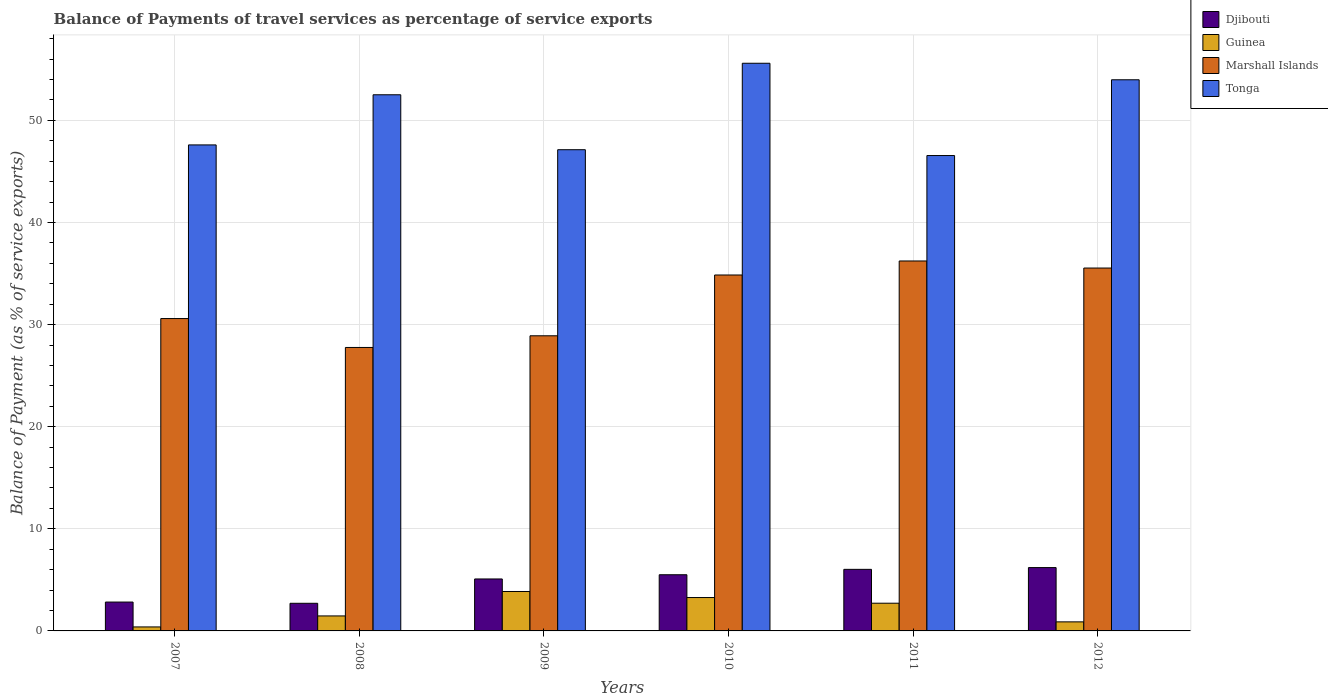How many groups of bars are there?
Give a very brief answer. 6. Are the number of bars on each tick of the X-axis equal?
Your response must be concise. Yes. How many bars are there on the 6th tick from the right?
Provide a short and direct response. 4. What is the balance of payments of travel services in Guinea in 2009?
Offer a terse response. 3.86. Across all years, what is the maximum balance of payments of travel services in Guinea?
Keep it short and to the point. 3.86. Across all years, what is the minimum balance of payments of travel services in Guinea?
Ensure brevity in your answer.  0.39. In which year was the balance of payments of travel services in Guinea minimum?
Keep it short and to the point. 2007. What is the total balance of payments of travel services in Guinea in the graph?
Keep it short and to the point. 12.59. What is the difference between the balance of payments of travel services in Djibouti in 2010 and that in 2011?
Keep it short and to the point. -0.53. What is the difference between the balance of payments of travel services in Tonga in 2008 and the balance of payments of travel services in Marshall Islands in 2010?
Your response must be concise. 17.65. What is the average balance of payments of travel services in Djibouti per year?
Keep it short and to the point. 4.73. In the year 2011, what is the difference between the balance of payments of travel services in Tonga and balance of payments of travel services in Marshall Islands?
Provide a short and direct response. 10.32. In how many years, is the balance of payments of travel services in Guinea greater than 10 %?
Your answer should be compact. 0. What is the ratio of the balance of payments of travel services in Guinea in 2009 to that in 2010?
Offer a terse response. 1.18. Is the balance of payments of travel services in Tonga in 2007 less than that in 2012?
Your response must be concise. Yes. Is the difference between the balance of payments of travel services in Tonga in 2010 and 2012 greater than the difference between the balance of payments of travel services in Marshall Islands in 2010 and 2012?
Your response must be concise. Yes. What is the difference between the highest and the second highest balance of payments of travel services in Guinea?
Provide a succinct answer. 0.59. What is the difference between the highest and the lowest balance of payments of travel services in Guinea?
Offer a very short reply. 3.47. Is the sum of the balance of payments of travel services in Marshall Islands in 2007 and 2012 greater than the maximum balance of payments of travel services in Tonga across all years?
Provide a short and direct response. Yes. What does the 3rd bar from the left in 2007 represents?
Offer a terse response. Marshall Islands. What does the 1st bar from the right in 2011 represents?
Your answer should be very brief. Tonga. How many years are there in the graph?
Provide a succinct answer. 6. Where does the legend appear in the graph?
Make the answer very short. Top right. What is the title of the graph?
Keep it short and to the point. Balance of Payments of travel services as percentage of service exports. What is the label or title of the Y-axis?
Keep it short and to the point. Balance of Payment (as % of service exports). What is the Balance of Payment (as % of service exports) in Djibouti in 2007?
Keep it short and to the point. 2.83. What is the Balance of Payment (as % of service exports) in Guinea in 2007?
Ensure brevity in your answer.  0.39. What is the Balance of Payment (as % of service exports) in Marshall Islands in 2007?
Your answer should be compact. 30.59. What is the Balance of Payment (as % of service exports) in Tonga in 2007?
Provide a succinct answer. 47.6. What is the Balance of Payment (as % of service exports) in Djibouti in 2008?
Offer a terse response. 2.71. What is the Balance of Payment (as % of service exports) of Guinea in 2008?
Provide a succinct answer. 1.47. What is the Balance of Payment (as % of service exports) of Marshall Islands in 2008?
Make the answer very short. 27.76. What is the Balance of Payment (as % of service exports) in Tonga in 2008?
Your answer should be very brief. 52.51. What is the Balance of Payment (as % of service exports) of Djibouti in 2009?
Make the answer very short. 5.09. What is the Balance of Payment (as % of service exports) in Guinea in 2009?
Your response must be concise. 3.86. What is the Balance of Payment (as % of service exports) of Marshall Islands in 2009?
Your answer should be very brief. 28.9. What is the Balance of Payment (as % of service exports) in Tonga in 2009?
Your answer should be very brief. 47.13. What is the Balance of Payment (as % of service exports) of Djibouti in 2010?
Ensure brevity in your answer.  5.5. What is the Balance of Payment (as % of service exports) in Guinea in 2010?
Provide a short and direct response. 3.27. What is the Balance of Payment (as % of service exports) in Marshall Islands in 2010?
Provide a succinct answer. 34.86. What is the Balance of Payment (as % of service exports) in Tonga in 2010?
Keep it short and to the point. 55.59. What is the Balance of Payment (as % of service exports) of Djibouti in 2011?
Provide a short and direct response. 6.03. What is the Balance of Payment (as % of service exports) of Guinea in 2011?
Give a very brief answer. 2.71. What is the Balance of Payment (as % of service exports) of Marshall Islands in 2011?
Offer a very short reply. 36.23. What is the Balance of Payment (as % of service exports) in Tonga in 2011?
Make the answer very short. 46.55. What is the Balance of Payment (as % of service exports) in Djibouti in 2012?
Your answer should be compact. 6.2. What is the Balance of Payment (as % of service exports) of Guinea in 2012?
Ensure brevity in your answer.  0.89. What is the Balance of Payment (as % of service exports) in Marshall Islands in 2012?
Your response must be concise. 35.54. What is the Balance of Payment (as % of service exports) in Tonga in 2012?
Offer a very short reply. 53.97. Across all years, what is the maximum Balance of Payment (as % of service exports) of Djibouti?
Keep it short and to the point. 6.2. Across all years, what is the maximum Balance of Payment (as % of service exports) of Guinea?
Your response must be concise. 3.86. Across all years, what is the maximum Balance of Payment (as % of service exports) in Marshall Islands?
Make the answer very short. 36.23. Across all years, what is the maximum Balance of Payment (as % of service exports) of Tonga?
Provide a succinct answer. 55.59. Across all years, what is the minimum Balance of Payment (as % of service exports) in Djibouti?
Keep it short and to the point. 2.71. Across all years, what is the minimum Balance of Payment (as % of service exports) of Guinea?
Your answer should be compact. 0.39. Across all years, what is the minimum Balance of Payment (as % of service exports) of Marshall Islands?
Offer a terse response. 27.76. Across all years, what is the minimum Balance of Payment (as % of service exports) in Tonga?
Provide a short and direct response. 46.55. What is the total Balance of Payment (as % of service exports) of Djibouti in the graph?
Ensure brevity in your answer.  28.36. What is the total Balance of Payment (as % of service exports) in Guinea in the graph?
Make the answer very short. 12.59. What is the total Balance of Payment (as % of service exports) in Marshall Islands in the graph?
Your response must be concise. 193.88. What is the total Balance of Payment (as % of service exports) of Tonga in the graph?
Your response must be concise. 303.35. What is the difference between the Balance of Payment (as % of service exports) in Djibouti in 2007 and that in 2008?
Give a very brief answer. 0.12. What is the difference between the Balance of Payment (as % of service exports) in Guinea in 2007 and that in 2008?
Your answer should be compact. -1.08. What is the difference between the Balance of Payment (as % of service exports) in Marshall Islands in 2007 and that in 2008?
Your answer should be very brief. 2.83. What is the difference between the Balance of Payment (as % of service exports) of Tonga in 2007 and that in 2008?
Give a very brief answer. -4.91. What is the difference between the Balance of Payment (as % of service exports) in Djibouti in 2007 and that in 2009?
Your answer should be compact. -2.26. What is the difference between the Balance of Payment (as % of service exports) in Guinea in 2007 and that in 2009?
Offer a terse response. -3.47. What is the difference between the Balance of Payment (as % of service exports) of Marshall Islands in 2007 and that in 2009?
Provide a succinct answer. 1.69. What is the difference between the Balance of Payment (as % of service exports) in Tonga in 2007 and that in 2009?
Give a very brief answer. 0.47. What is the difference between the Balance of Payment (as % of service exports) in Djibouti in 2007 and that in 2010?
Provide a succinct answer. -2.67. What is the difference between the Balance of Payment (as % of service exports) in Guinea in 2007 and that in 2010?
Keep it short and to the point. -2.88. What is the difference between the Balance of Payment (as % of service exports) of Marshall Islands in 2007 and that in 2010?
Offer a very short reply. -4.27. What is the difference between the Balance of Payment (as % of service exports) of Tonga in 2007 and that in 2010?
Provide a short and direct response. -8. What is the difference between the Balance of Payment (as % of service exports) of Djibouti in 2007 and that in 2011?
Provide a short and direct response. -3.2. What is the difference between the Balance of Payment (as % of service exports) of Guinea in 2007 and that in 2011?
Your answer should be compact. -2.32. What is the difference between the Balance of Payment (as % of service exports) of Marshall Islands in 2007 and that in 2011?
Offer a very short reply. -5.64. What is the difference between the Balance of Payment (as % of service exports) in Tonga in 2007 and that in 2011?
Offer a terse response. 1.04. What is the difference between the Balance of Payment (as % of service exports) in Djibouti in 2007 and that in 2012?
Provide a succinct answer. -3.38. What is the difference between the Balance of Payment (as % of service exports) of Guinea in 2007 and that in 2012?
Provide a succinct answer. -0.5. What is the difference between the Balance of Payment (as % of service exports) of Marshall Islands in 2007 and that in 2012?
Make the answer very short. -4.95. What is the difference between the Balance of Payment (as % of service exports) in Tonga in 2007 and that in 2012?
Offer a very short reply. -6.38. What is the difference between the Balance of Payment (as % of service exports) in Djibouti in 2008 and that in 2009?
Give a very brief answer. -2.38. What is the difference between the Balance of Payment (as % of service exports) of Guinea in 2008 and that in 2009?
Offer a very short reply. -2.39. What is the difference between the Balance of Payment (as % of service exports) in Marshall Islands in 2008 and that in 2009?
Make the answer very short. -1.14. What is the difference between the Balance of Payment (as % of service exports) of Tonga in 2008 and that in 2009?
Offer a very short reply. 5.38. What is the difference between the Balance of Payment (as % of service exports) of Djibouti in 2008 and that in 2010?
Make the answer very short. -2.79. What is the difference between the Balance of Payment (as % of service exports) in Guinea in 2008 and that in 2010?
Offer a terse response. -1.8. What is the difference between the Balance of Payment (as % of service exports) of Marshall Islands in 2008 and that in 2010?
Your response must be concise. -7.1. What is the difference between the Balance of Payment (as % of service exports) of Tonga in 2008 and that in 2010?
Your answer should be very brief. -3.09. What is the difference between the Balance of Payment (as % of service exports) of Djibouti in 2008 and that in 2011?
Your response must be concise. -3.32. What is the difference between the Balance of Payment (as % of service exports) of Guinea in 2008 and that in 2011?
Keep it short and to the point. -1.25. What is the difference between the Balance of Payment (as % of service exports) of Marshall Islands in 2008 and that in 2011?
Your response must be concise. -8.47. What is the difference between the Balance of Payment (as % of service exports) in Tonga in 2008 and that in 2011?
Provide a succinct answer. 5.95. What is the difference between the Balance of Payment (as % of service exports) in Djibouti in 2008 and that in 2012?
Provide a short and direct response. -3.5. What is the difference between the Balance of Payment (as % of service exports) of Guinea in 2008 and that in 2012?
Keep it short and to the point. 0.58. What is the difference between the Balance of Payment (as % of service exports) of Marshall Islands in 2008 and that in 2012?
Give a very brief answer. -7.78. What is the difference between the Balance of Payment (as % of service exports) of Tonga in 2008 and that in 2012?
Provide a short and direct response. -1.47. What is the difference between the Balance of Payment (as % of service exports) of Djibouti in 2009 and that in 2010?
Keep it short and to the point. -0.41. What is the difference between the Balance of Payment (as % of service exports) in Guinea in 2009 and that in 2010?
Your answer should be very brief. 0.59. What is the difference between the Balance of Payment (as % of service exports) in Marshall Islands in 2009 and that in 2010?
Offer a terse response. -5.95. What is the difference between the Balance of Payment (as % of service exports) of Tonga in 2009 and that in 2010?
Your answer should be very brief. -8.47. What is the difference between the Balance of Payment (as % of service exports) of Djibouti in 2009 and that in 2011?
Provide a succinct answer. -0.94. What is the difference between the Balance of Payment (as % of service exports) of Guinea in 2009 and that in 2011?
Your answer should be compact. 1.15. What is the difference between the Balance of Payment (as % of service exports) in Marshall Islands in 2009 and that in 2011?
Give a very brief answer. -7.33. What is the difference between the Balance of Payment (as % of service exports) of Tonga in 2009 and that in 2011?
Provide a succinct answer. 0.57. What is the difference between the Balance of Payment (as % of service exports) in Djibouti in 2009 and that in 2012?
Keep it short and to the point. -1.11. What is the difference between the Balance of Payment (as % of service exports) of Guinea in 2009 and that in 2012?
Offer a terse response. 2.98. What is the difference between the Balance of Payment (as % of service exports) in Marshall Islands in 2009 and that in 2012?
Your answer should be very brief. -6.64. What is the difference between the Balance of Payment (as % of service exports) in Tonga in 2009 and that in 2012?
Ensure brevity in your answer.  -6.85. What is the difference between the Balance of Payment (as % of service exports) in Djibouti in 2010 and that in 2011?
Keep it short and to the point. -0.53. What is the difference between the Balance of Payment (as % of service exports) of Guinea in 2010 and that in 2011?
Give a very brief answer. 0.55. What is the difference between the Balance of Payment (as % of service exports) of Marshall Islands in 2010 and that in 2011?
Provide a succinct answer. -1.37. What is the difference between the Balance of Payment (as % of service exports) of Tonga in 2010 and that in 2011?
Keep it short and to the point. 9.04. What is the difference between the Balance of Payment (as % of service exports) in Djibouti in 2010 and that in 2012?
Your answer should be compact. -0.7. What is the difference between the Balance of Payment (as % of service exports) of Guinea in 2010 and that in 2012?
Give a very brief answer. 2.38. What is the difference between the Balance of Payment (as % of service exports) of Marshall Islands in 2010 and that in 2012?
Keep it short and to the point. -0.68. What is the difference between the Balance of Payment (as % of service exports) in Tonga in 2010 and that in 2012?
Ensure brevity in your answer.  1.62. What is the difference between the Balance of Payment (as % of service exports) in Djibouti in 2011 and that in 2012?
Provide a short and direct response. -0.17. What is the difference between the Balance of Payment (as % of service exports) of Guinea in 2011 and that in 2012?
Your answer should be compact. 1.83. What is the difference between the Balance of Payment (as % of service exports) of Marshall Islands in 2011 and that in 2012?
Your answer should be very brief. 0.69. What is the difference between the Balance of Payment (as % of service exports) of Tonga in 2011 and that in 2012?
Offer a terse response. -7.42. What is the difference between the Balance of Payment (as % of service exports) in Djibouti in 2007 and the Balance of Payment (as % of service exports) in Guinea in 2008?
Keep it short and to the point. 1.36. What is the difference between the Balance of Payment (as % of service exports) in Djibouti in 2007 and the Balance of Payment (as % of service exports) in Marshall Islands in 2008?
Your answer should be very brief. -24.93. What is the difference between the Balance of Payment (as % of service exports) of Djibouti in 2007 and the Balance of Payment (as % of service exports) of Tonga in 2008?
Keep it short and to the point. -49.68. What is the difference between the Balance of Payment (as % of service exports) of Guinea in 2007 and the Balance of Payment (as % of service exports) of Marshall Islands in 2008?
Provide a short and direct response. -27.37. What is the difference between the Balance of Payment (as % of service exports) of Guinea in 2007 and the Balance of Payment (as % of service exports) of Tonga in 2008?
Keep it short and to the point. -52.12. What is the difference between the Balance of Payment (as % of service exports) in Marshall Islands in 2007 and the Balance of Payment (as % of service exports) in Tonga in 2008?
Provide a succinct answer. -21.92. What is the difference between the Balance of Payment (as % of service exports) of Djibouti in 2007 and the Balance of Payment (as % of service exports) of Guinea in 2009?
Offer a terse response. -1.04. What is the difference between the Balance of Payment (as % of service exports) in Djibouti in 2007 and the Balance of Payment (as % of service exports) in Marshall Islands in 2009?
Give a very brief answer. -26.08. What is the difference between the Balance of Payment (as % of service exports) in Djibouti in 2007 and the Balance of Payment (as % of service exports) in Tonga in 2009?
Offer a terse response. -44.3. What is the difference between the Balance of Payment (as % of service exports) in Guinea in 2007 and the Balance of Payment (as % of service exports) in Marshall Islands in 2009?
Offer a terse response. -28.51. What is the difference between the Balance of Payment (as % of service exports) in Guinea in 2007 and the Balance of Payment (as % of service exports) in Tonga in 2009?
Provide a succinct answer. -46.74. What is the difference between the Balance of Payment (as % of service exports) of Marshall Islands in 2007 and the Balance of Payment (as % of service exports) of Tonga in 2009?
Ensure brevity in your answer.  -16.54. What is the difference between the Balance of Payment (as % of service exports) in Djibouti in 2007 and the Balance of Payment (as % of service exports) in Guinea in 2010?
Keep it short and to the point. -0.44. What is the difference between the Balance of Payment (as % of service exports) of Djibouti in 2007 and the Balance of Payment (as % of service exports) of Marshall Islands in 2010?
Provide a succinct answer. -32.03. What is the difference between the Balance of Payment (as % of service exports) in Djibouti in 2007 and the Balance of Payment (as % of service exports) in Tonga in 2010?
Provide a succinct answer. -52.77. What is the difference between the Balance of Payment (as % of service exports) of Guinea in 2007 and the Balance of Payment (as % of service exports) of Marshall Islands in 2010?
Your response must be concise. -34.47. What is the difference between the Balance of Payment (as % of service exports) of Guinea in 2007 and the Balance of Payment (as % of service exports) of Tonga in 2010?
Offer a very short reply. -55.2. What is the difference between the Balance of Payment (as % of service exports) in Marshall Islands in 2007 and the Balance of Payment (as % of service exports) in Tonga in 2010?
Offer a terse response. -25. What is the difference between the Balance of Payment (as % of service exports) of Djibouti in 2007 and the Balance of Payment (as % of service exports) of Guinea in 2011?
Provide a short and direct response. 0.11. What is the difference between the Balance of Payment (as % of service exports) of Djibouti in 2007 and the Balance of Payment (as % of service exports) of Marshall Islands in 2011?
Your answer should be very brief. -33.4. What is the difference between the Balance of Payment (as % of service exports) in Djibouti in 2007 and the Balance of Payment (as % of service exports) in Tonga in 2011?
Offer a terse response. -43.73. What is the difference between the Balance of Payment (as % of service exports) in Guinea in 2007 and the Balance of Payment (as % of service exports) in Marshall Islands in 2011?
Your response must be concise. -35.84. What is the difference between the Balance of Payment (as % of service exports) of Guinea in 2007 and the Balance of Payment (as % of service exports) of Tonga in 2011?
Give a very brief answer. -46.16. What is the difference between the Balance of Payment (as % of service exports) of Marshall Islands in 2007 and the Balance of Payment (as % of service exports) of Tonga in 2011?
Provide a succinct answer. -15.96. What is the difference between the Balance of Payment (as % of service exports) in Djibouti in 2007 and the Balance of Payment (as % of service exports) in Guinea in 2012?
Give a very brief answer. 1.94. What is the difference between the Balance of Payment (as % of service exports) of Djibouti in 2007 and the Balance of Payment (as % of service exports) of Marshall Islands in 2012?
Provide a succinct answer. -32.71. What is the difference between the Balance of Payment (as % of service exports) in Djibouti in 2007 and the Balance of Payment (as % of service exports) in Tonga in 2012?
Give a very brief answer. -51.15. What is the difference between the Balance of Payment (as % of service exports) in Guinea in 2007 and the Balance of Payment (as % of service exports) in Marshall Islands in 2012?
Offer a terse response. -35.15. What is the difference between the Balance of Payment (as % of service exports) in Guinea in 2007 and the Balance of Payment (as % of service exports) in Tonga in 2012?
Your answer should be very brief. -53.58. What is the difference between the Balance of Payment (as % of service exports) of Marshall Islands in 2007 and the Balance of Payment (as % of service exports) of Tonga in 2012?
Provide a short and direct response. -23.38. What is the difference between the Balance of Payment (as % of service exports) of Djibouti in 2008 and the Balance of Payment (as % of service exports) of Guinea in 2009?
Provide a short and direct response. -1.16. What is the difference between the Balance of Payment (as % of service exports) in Djibouti in 2008 and the Balance of Payment (as % of service exports) in Marshall Islands in 2009?
Ensure brevity in your answer.  -26.2. What is the difference between the Balance of Payment (as % of service exports) of Djibouti in 2008 and the Balance of Payment (as % of service exports) of Tonga in 2009?
Provide a short and direct response. -44.42. What is the difference between the Balance of Payment (as % of service exports) in Guinea in 2008 and the Balance of Payment (as % of service exports) in Marshall Islands in 2009?
Offer a terse response. -27.44. What is the difference between the Balance of Payment (as % of service exports) of Guinea in 2008 and the Balance of Payment (as % of service exports) of Tonga in 2009?
Make the answer very short. -45.66. What is the difference between the Balance of Payment (as % of service exports) in Marshall Islands in 2008 and the Balance of Payment (as % of service exports) in Tonga in 2009?
Make the answer very short. -19.37. What is the difference between the Balance of Payment (as % of service exports) in Djibouti in 2008 and the Balance of Payment (as % of service exports) in Guinea in 2010?
Provide a short and direct response. -0.56. What is the difference between the Balance of Payment (as % of service exports) in Djibouti in 2008 and the Balance of Payment (as % of service exports) in Marshall Islands in 2010?
Give a very brief answer. -32.15. What is the difference between the Balance of Payment (as % of service exports) of Djibouti in 2008 and the Balance of Payment (as % of service exports) of Tonga in 2010?
Ensure brevity in your answer.  -52.89. What is the difference between the Balance of Payment (as % of service exports) in Guinea in 2008 and the Balance of Payment (as % of service exports) in Marshall Islands in 2010?
Your response must be concise. -33.39. What is the difference between the Balance of Payment (as % of service exports) of Guinea in 2008 and the Balance of Payment (as % of service exports) of Tonga in 2010?
Offer a very short reply. -54.13. What is the difference between the Balance of Payment (as % of service exports) in Marshall Islands in 2008 and the Balance of Payment (as % of service exports) in Tonga in 2010?
Give a very brief answer. -27.83. What is the difference between the Balance of Payment (as % of service exports) of Djibouti in 2008 and the Balance of Payment (as % of service exports) of Guinea in 2011?
Your answer should be compact. -0.01. What is the difference between the Balance of Payment (as % of service exports) of Djibouti in 2008 and the Balance of Payment (as % of service exports) of Marshall Islands in 2011?
Your response must be concise. -33.52. What is the difference between the Balance of Payment (as % of service exports) of Djibouti in 2008 and the Balance of Payment (as % of service exports) of Tonga in 2011?
Provide a succinct answer. -43.85. What is the difference between the Balance of Payment (as % of service exports) in Guinea in 2008 and the Balance of Payment (as % of service exports) in Marshall Islands in 2011?
Make the answer very short. -34.76. What is the difference between the Balance of Payment (as % of service exports) in Guinea in 2008 and the Balance of Payment (as % of service exports) in Tonga in 2011?
Keep it short and to the point. -45.09. What is the difference between the Balance of Payment (as % of service exports) in Marshall Islands in 2008 and the Balance of Payment (as % of service exports) in Tonga in 2011?
Offer a very short reply. -18.8. What is the difference between the Balance of Payment (as % of service exports) of Djibouti in 2008 and the Balance of Payment (as % of service exports) of Guinea in 2012?
Provide a succinct answer. 1.82. What is the difference between the Balance of Payment (as % of service exports) in Djibouti in 2008 and the Balance of Payment (as % of service exports) in Marshall Islands in 2012?
Offer a terse response. -32.83. What is the difference between the Balance of Payment (as % of service exports) in Djibouti in 2008 and the Balance of Payment (as % of service exports) in Tonga in 2012?
Provide a succinct answer. -51.27. What is the difference between the Balance of Payment (as % of service exports) of Guinea in 2008 and the Balance of Payment (as % of service exports) of Marshall Islands in 2012?
Make the answer very short. -34.07. What is the difference between the Balance of Payment (as % of service exports) in Guinea in 2008 and the Balance of Payment (as % of service exports) in Tonga in 2012?
Provide a short and direct response. -52.51. What is the difference between the Balance of Payment (as % of service exports) of Marshall Islands in 2008 and the Balance of Payment (as % of service exports) of Tonga in 2012?
Keep it short and to the point. -26.22. What is the difference between the Balance of Payment (as % of service exports) in Djibouti in 2009 and the Balance of Payment (as % of service exports) in Guinea in 2010?
Ensure brevity in your answer.  1.82. What is the difference between the Balance of Payment (as % of service exports) in Djibouti in 2009 and the Balance of Payment (as % of service exports) in Marshall Islands in 2010?
Provide a short and direct response. -29.77. What is the difference between the Balance of Payment (as % of service exports) in Djibouti in 2009 and the Balance of Payment (as % of service exports) in Tonga in 2010?
Your response must be concise. -50.5. What is the difference between the Balance of Payment (as % of service exports) in Guinea in 2009 and the Balance of Payment (as % of service exports) in Marshall Islands in 2010?
Give a very brief answer. -30.99. What is the difference between the Balance of Payment (as % of service exports) in Guinea in 2009 and the Balance of Payment (as % of service exports) in Tonga in 2010?
Give a very brief answer. -51.73. What is the difference between the Balance of Payment (as % of service exports) of Marshall Islands in 2009 and the Balance of Payment (as % of service exports) of Tonga in 2010?
Make the answer very short. -26.69. What is the difference between the Balance of Payment (as % of service exports) of Djibouti in 2009 and the Balance of Payment (as % of service exports) of Guinea in 2011?
Your answer should be compact. 2.38. What is the difference between the Balance of Payment (as % of service exports) of Djibouti in 2009 and the Balance of Payment (as % of service exports) of Marshall Islands in 2011?
Ensure brevity in your answer.  -31.14. What is the difference between the Balance of Payment (as % of service exports) of Djibouti in 2009 and the Balance of Payment (as % of service exports) of Tonga in 2011?
Your answer should be very brief. -41.47. What is the difference between the Balance of Payment (as % of service exports) of Guinea in 2009 and the Balance of Payment (as % of service exports) of Marshall Islands in 2011?
Offer a very short reply. -32.37. What is the difference between the Balance of Payment (as % of service exports) of Guinea in 2009 and the Balance of Payment (as % of service exports) of Tonga in 2011?
Ensure brevity in your answer.  -42.69. What is the difference between the Balance of Payment (as % of service exports) of Marshall Islands in 2009 and the Balance of Payment (as % of service exports) of Tonga in 2011?
Give a very brief answer. -17.65. What is the difference between the Balance of Payment (as % of service exports) of Djibouti in 2009 and the Balance of Payment (as % of service exports) of Guinea in 2012?
Your response must be concise. 4.2. What is the difference between the Balance of Payment (as % of service exports) in Djibouti in 2009 and the Balance of Payment (as % of service exports) in Marshall Islands in 2012?
Your answer should be very brief. -30.45. What is the difference between the Balance of Payment (as % of service exports) in Djibouti in 2009 and the Balance of Payment (as % of service exports) in Tonga in 2012?
Your answer should be compact. -48.89. What is the difference between the Balance of Payment (as % of service exports) of Guinea in 2009 and the Balance of Payment (as % of service exports) of Marshall Islands in 2012?
Keep it short and to the point. -31.68. What is the difference between the Balance of Payment (as % of service exports) of Guinea in 2009 and the Balance of Payment (as % of service exports) of Tonga in 2012?
Make the answer very short. -50.11. What is the difference between the Balance of Payment (as % of service exports) of Marshall Islands in 2009 and the Balance of Payment (as % of service exports) of Tonga in 2012?
Your response must be concise. -25.07. What is the difference between the Balance of Payment (as % of service exports) of Djibouti in 2010 and the Balance of Payment (as % of service exports) of Guinea in 2011?
Your response must be concise. 2.79. What is the difference between the Balance of Payment (as % of service exports) of Djibouti in 2010 and the Balance of Payment (as % of service exports) of Marshall Islands in 2011?
Offer a very short reply. -30.73. What is the difference between the Balance of Payment (as % of service exports) of Djibouti in 2010 and the Balance of Payment (as % of service exports) of Tonga in 2011?
Offer a terse response. -41.05. What is the difference between the Balance of Payment (as % of service exports) in Guinea in 2010 and the Balance of Payment (as % of service exports) in Marshall Islands in 2011?
Provide a succinct answer. -32.96. What is the difference between the Balance of Payment (as % of service exports) of Guinea in 2010 and the Balance of Payment (as % of service exports) of Tonga in 2011?
Provide a short and direct response. -43.29. What is the difference between the Balance of Payment (as % of service exports) in Marshall Islands in 2010 and the Balance of Payment (as % of service exports) in Tonga in 2011?
Offer a terse response. -11.7. What is the difference between the Balance of Payment (as % of service exports) in Djibouti in 2010 and the Balance of Payment (as % of service exports) in Guinea in 2012?
Keep it short and to the point. 4.61. What is the difference between the Balance of Payment (as % of service exports) of Djibouti in 2010 and the Balance of Payment (as % of service exports) of Marshall Islands in 2012?
Make the answer very short. -30.04. What is the difference between the Balance of Payment (as % of service exports) in Djibouti in 2010 and the Balance of Payment (as % of service exports) in Tonga in 2012?
Provide a short and direct response. -48.47. What is the difference between the Balance of Payment (as % of service exports) in Guinea in 2010 and the Balance of Payment (as % of service exports) in Marshall Islands in 2012?
Provide a short and direct response. -32.27. What is the difference between the Balance of Payment (as % of service exports) in Guinea in 2010 and the Balance of Payment (as % of service exports) in Tonga in 2012?
Your answer should be compact. -50.71. What is the difference between the Balance of Payment (as % of service exports) of Marshall Islands in 2010 and the Balance of Payment (as % of service exports) of Tonga in 2012?
Provide a short and direct response. -19.12. What is the difference between the Balance of Payment (as % of service exports) of Djibouti in 2011 and the Balance of Payment (as % of service exports) of Guinea in 2012?
Offer a very short reply. 5.14. What is the difference between the Balance of Payment (as % of service exports) of Djibouti in 2011 and the Balance of Payment (as % of service exports) of Marshall Islands in 2012?
Offer a terse response. -29.51. What is the difference between the Balance of Payment (as % of service exports) in Djibouti in 2011 and the Balance of Payment (as % of service exports) in Tonga in 2012?
Your answer should be compact. -47.94. What is the difference between the Balance of Payment (as % of service exports) in Guinea in 2011 and the Balance of Payment (as % of service exports) in Marshall Islands in 2012?
Your answer should be very brief. -32.82. What is the difference between the Balance of Payment (as % of service exports) in Guinea in 2011 and the Balance of Payment (as % of service exports) in Tonga in 2012?
Your response must be concise. -51.26. What is the difference between the Balance of Payment (as % of service exports) of Marshall Islands in 2011 and the Balance of Payment (as % of service exports) of Tonga in 2012?
Give a very brief answer. -17.74. What is the average Balance of Payment (as % of service exports) in Djibouti per year?
Your response must be concise. 4.73. What is the average Balance of Payment (as % of service exports) of Guinea per year?
Offer a very short reply. 2.1. What is the average Balance of Payment (as % of service exports) in Marshall Islands per year?
Offer a very short reply. 32.31. What is the average Balance of Payment (as % of service exports) of Tonga per year?
Your answer should be compact. 50.56. In the year 2007, what is the difference between the Balance of Payment (as % of service exports) of Djibouti and Balance of Payment (as % of service exports) of Guinea?
Provide a succinct answer. 2.44. In the year 2007, what is the difference between the Balance of Payment (as % of service exports) in Djibouti and Balance of Payment (as % of service exports) in Marshall Islands?
Give a very brief answer. -27.76. In the year 2007, what is the difference between the Balance of Payment (as % of service exports) in Djibouti and Balance of Payment (as % of service exports) in Tonga?
Your response must be concise. -44.77. In the year 2007, what is the difference between the Balance of Payment (as % of service exports) in Guinea and Balance of Payment (as % of service exports) in Marshall Islands?
Give a very brief answer. -30.2. In the year 2007, what is the difference between the Balance of Payment (as % of service exports) in Guinea and Balance of Payment (as % of service exports) in Tonga?
Give a very brief answer. -47.21. In the year 2007, what is the difference between the Balance of Payment (as % of service exports) in Marshall Islands and Balance of Payment (as % of service exports) in Tonga?
Make the answer very short. -17.01. In the year 2008, what is the difference between the Balance of Payment (as % of service exports) in Djibouti and Balance of Payment (as % of service exports) in Guinea?
Keep it short and to the point. 1.24. In the year 2008, what is the difference between the Balance of Payment (as % of service exports) in Djibouti and Balance of Payment (as % of service exports) in Marshall Islands?
Your response must be concise. -25.05. In the year 2008, what is the difference between the Balance of Payment (as % of service exports) in Djibouti and Balance of Payment (as % of service exports) in Tonga?
Your answer should be very brief. -49.8. In the year 2008, what is the difference between the Balance of Payment (as % of service exports) in Guinea and Balance of Payment (as % of service exports) in Marshall Islands?
Give a very brief answer. -26.29. In the year 2008, what is the difference between the Balance of Payment (as % of service exports) in Guinea and Balance of Payment (as % of service exports) in Tonga?
Make the answer very short. -51.04. In the year 2008, what is the difference between the Balance of Payment (as % of service exports) in Marshall Islands and Balance of Payment (as % of service exports) in Tonga?
Make the answer very short. -24.75. In the year 2009, what is the difference between the Balance of Payment (as % of service exports) in Djibouti and Balance of Payment (as % of service exports) in Guinea?
Make the answer very short. 1.23. In the year 2009, what is the difference between the Balance of Payment (as % of service exports) of Djibouti and Balance of Payment (as % of service exports) of Marshall Islands?
Provide a succinct answer. -23.81. In the year 2009, what is the difference between the Balance of Payment (as % of service exports) in Djibouti and Balance of Payment (as % of service exports) in Tonga?
Offer a very short reply. -42.04. In the year 2009, what is the difference between the Balance of Payment (as % of service exports) in Guinea and Balance of Payment (as % of service exports) in Marshall Islands?
Your answer should be compact. -25.04. In the year 2009, what is the difference between the Balance of Payment (as % of service exports) in Guinea and Balance of Payment (as % of service exports) in Tonga?
Offer a very short reply. -43.26. In the year 2009, what is the difference between the Balance of Payment (as % of service exports) of Marshall Islands and Balance of Payment (as % of service exports) of Tonga?
Give a very brief answer. -18.22. In the year 2010, what is the difference between the Balance of Payment (as % of service exports) in Djibouti and Balance of Payment (as % of service exports) in Guinea?
Offer a very short reply. 2.23. In the year 2010, what is the difference between the Balance of Payment (as % of service exports) in Djibouti and Balance of Payment (as % of service exports) in Marshall Islands?
Your answer should be compact. -29.36. In the year 2010, what is the difference between the Balance of Payment (as % of service exports) in Djibouti and Balance of Payment (as % of service exports) in Tonga?
Make the answer very short. -50.09. In the year 2010, what is the difference between the Balance of Payment (as % of service exports) of Guinea and Balance of Payment (as % of service exports) of Marshall Islands?
Your response must be concise. -31.59. In the year 2010, what is the difference between the Balance of Payment (as % of service exports) of Guinea and Balance of Payment (as % of service exports) of Tonga?
Make the answer very short. -52.32. In the year 2010, what is the difference between the Balance of Payment (as % of service exports) in Marshall Islands and Balance of Payment (as % of service exports) in Tonga?
Your response must be concise. -20.74. In the year 2011, what is the difference between the Balance of Payment (as % of service exports) of Djibouti and Balance of Payment (as % of service exports) of Guinea?
Make the answer very short. 3.32. In the year 2011, what is the difference between the Balance of Payment (as % of service exports) in Djibouti and Balance of Payment (as % of service exports) in Marshall Islands?
Your answer should be compact. -30.2. In the year 2011, what is the difference between the Balance of Payment (as % of service exports) of Djibouti and Balance of Payment (as % of service exports) of Tonga?
Your response must be concise. -40.52. In the year 2011, what is the difference between the Balance of Payment (as % of service exports) of Guinea and Balance of Payment (as % of service exports) of Marshall Islands?
Give a very brief answer. -33.52. In the year 2011, what is the difference between the Balance of Payment (as % of service exports) in Guinea and Balance of Payment (as % of service exports) in Tonga?
Ensure brevity in your answer.  -43.84. In the year 2011, what is the difference between the Balance of Payment (as % of service exports) in Marshall Islands and Balance of Payment (as % of service exports) in Tonga?
Ensure brevity in your answer.  -10.32. In the year 2012, what is the difference between the Balance of Payment (as % of service exports) of Djibouti and Balance of Payment (as % of service exports) of Guinea?
Ensure brevity in your answer.  5.32. In the year 2012, what is the difference between the Balance of Payment (as % of service exports) in Djibouti and Balance of Payment (as % of service exports) in Marshall Islands?
Make the answer very short. -29.34. In the year 2012, what is the difference between the Balance of Payment (as % of service exports) in Djibouti and Balance of Payment (as % of service exports) in Tonga?
Your answer should be very brief. -47.77. In the year 2012, what is the difference between the Balance of Payment (as % of service exports) in Guinea and Balance of Payment (as % of service exports) in Marshall Islands?
Your answer should be compact. -34.65. In the year 2012, what is the difference between the Balance of Payment (as % of service exports) of Guinea and Balance of Payment (as % of service exports) of Tonga?
Provide a short and direct response. -53.09. In the year 2012, what is the difference between the Balance of Payment (as % of service exports) in Marshall Islands and Balance of Payment (as % of service exports) in Tonga?
Ensure brevity in your answer.  -18.44. What is the ratio of the Balance of Payment (as % of service exports) of Djibouti in 2007 to that in 2008?
Ensure brevity in your answer.  1.04. What is the ratio of the Balance of Payment (as % of service exports) of Guinea in 2007 to that in 2008?
Provide a short and direct response. 0.27. What is the ratio of the Balance of Payment (as % of service exports) of Marshall Islands in 2007 to that in 2008?
Your answer should be compact. 1.1. What is the ratio of the Balance of Payment (as % of service exports) of Tonga in 2007 to that in 2008?
Your answer should be compact. 0.91. What is the ratio of the Balance of Payment (as % of service exports) of Djibouti in 2007 to that in 2009?
Provide a succinct answer. 0.56. What is the ratio of the Balance of Payment (as % of service exports) of Guinea in 2007 to that in 2009?
Your answer should be very brief. 0.1. What is the ratio of the Balance of Payment (as % of service exports) of Marshall Islands in 2007 to that in 2009?
Make the answer very short. 1.06. What is the ratio of the Balance of Payment (as % of service exports) in Djibouti in 2007 to that in 2010?
Provide a short and direct response. 0.51. What is the ratio of the Balance of Payment (as % of service exports) in Guinea in 2007 to that in 2010?
Ensure brevity in your answer.  0.12. What is the ratio of the Balance of Payment (as % of service exports) in Marshall Islands in 2007 to that in 2010?
Offer a very short reply. 0.88. What is the ratio of the Balance of Payment (as % of service exports) of Tonga in 2007 to that in 2010?
Provide a succinct answer. 0.86. What is the ratio of the Balance of Payment (as % of service exports) in Djibouti in 2007 to that in 2011?
Provide a succinct answer. 0.47. What is the ratio of the Balance of Payment (as % of service exports) of Guinea in 2007 to that in 2011?
Keep it short and to the point. 0.14. What is the ratio of the Balance of Payment (as % of service exports) in Marshall Islands in 2007 to that in 2011?
Provide a succinct answer. 0.84. What is the ratio of the Balance of Payment (as % of service exports) of Tonga in 2007 to that in 2011?
Your answer should be very brief. 1.02. What is the ratio of the Balance of Payment (as % of service exports) of Djibouti in 2007 to that in 2012?
Provide a succinct answer. 0.46. What is the ratio of the Balance of Payment (as % of service exports) in Guinea in 2007 to that in 2012?
Offer a very short reply. 0.44. What is the ratio of the Balance of Payment (as % of service exports) in Marshall Islands in 2007 to that in 2012?
Make the answer very short. 0.86. What is the ratio of the Balance of Payment (as % of service exports) in Tonga in 2007 to that in 2012?
Provide a short and direct response. 0.88. What is the ratio of the Balance of Payment (as % of service exports) of Djibouti in 2008 to that in 2009?
Your answer should be compact. 0.53. What is the ratio of the Balance of Payment (as % of service exports) in Guinea in 2008 to that in 2009?
Provide a short and direct response. 0.38. What is the ratio of the Balance of Payment (as % of service exports) of Marshall Islands in 2008 to that in 2009?
Provide a short and direct response. 0.96. What is the ratio of the Balance of Payment (as % of service exports) in Tonga in 2008 to that in 2009?
Offer a terse response. 1.11. What is the ratio of the Balance of Payment (as % of service exports) of Djibouti in 2008 to that in 2010?
Ensure brevity in your answer.  0.49. What is the ratio of the Balance of Payment (as % of service exports) in Guinea in 2008 to that in 2010?
Offer a very short reply. 0.45. What is the ratio of the Balance of Payment (as % of service exports) of Marshall Islands in 2008 to that in 2010?
Your answer should be very brief. 0.8. What is the ratio of the Balance of Payment (as % of service exports) of Tonga in 2008 to that in 2010?
Ensure brevity in your answer.  0.94. What is the ratio of the Balance of Payment (as % of service exports) of Djibouti in 2008 to that in 2011?
Make the answer very short. 0.45. What is the ratio of the Balance of Payment (as % of service exports) of Guinea in 2008 to that in 2011?
Your answer should be very brief. 0.54. What is the ratio of the Balance of Payment (as % of service exports) of Marshall Islands in 2008 to that in 2011?
Provide a succinct answer. 0.77. What is the ratio of the Balance of Payment (as % of service exports) in Tonga in 2008 to that in 2011?
Provide a short and direct response. 1.13. What is the ratio of the Balance of Payment (as % of service exports) in Djibouti in 2008 to that in 2012?
Keep it short and to the point. 0.44. What is the ratio of the Balance of Payment (as % of service exports) of Guinea in 2008 to that in 2012?
Your answer should be compact. 1.66. What is the ratio of the Balance of Payment (as % of service exports) of Marshall Islands in 2008 to that in 2012?
Make the answer very short. 0.78. What is the ratio of the Balance of Payment (as % of service exports) of Tonga in 2008 to that in 2012?
Offer a very short reply. 0.97. What is the ratio of the Balance of Payment (as % of service exports) in Djibouti in 2009 to that in 2010?
Provide a succinct answer. 0.93. What is the ratio of the Balance of Payment (as % of service exports) of Guinea in 2009 to that in 2010?
Offer a very short reply. 1.18. What is the ratio of the Balance of Payment (as % of service exports) of Marshall Islands in 2009 to that in 2010?
Your answer should be very brief. 0.83. What is the ratio of the Balance of Payment (as % of service exports) of Tonga in 2009 to that in 2010?
Provide a succinct answer. 0.85. What is the ratio of the Balance of Payment (as % of service exports) of Djibouti in 2009 to that in 2011?
Provide a succinct answer. 0.84. What is the ratio of the Balance of Payment (as % of service exports) of Guinea in 2009 to that in 2011?
Keep it short and to the point. 1.42. What is the ratio of the Balance of Payment (as % of service exports) of Marshall Islands in 2009 to that in 2011?
Your answer should be compact. 0.8. What is the ratio of the Balance of Payment (as % of service exports) of Tonga in 2009 to that in 2011?
Keep it short and to the point. 1.01. What is the ratio of the Balance of Payment (as % of service exports) of Djibouti in 2009 to that in 2012?
Ensure brevity in your answer.  0.82. What is the ratio of the Balance of Payment (as % of service exports) of Guinea in 2009 to that in 2012?
Provide a succinct answer. 4.36. What is the ratio of the Balance of Payment (as % of service exports) of Marshall Islands in 2009 to that in 2012?
Offer a very short reply. 0.81. What is the ratio of the Balance of Payment (as % of service exports) of Tonga in 2009 to that in 2012?
Provide a succinct answer. 0.87. What is the ratio of the Balance of Payment (as % of service exports) in Djibouti in 2010 to that in 2011?
Make the answer very short. 0.91. What is the ratio of the Balance of Payment (as % of service exports) in Guinea in 2010 to that in 2011?
Ensure brevity in your answer.  1.2. What is the ratio of the Balance of Payment (as % of service exports) of Marshall Islands in 2010 to that in 2011?
Offer a very short reply. 0.96. What is the ratio of the Balance of Payment (as % of service exports) in Tonga in 2010 to that in 2011?
Offer a terse response. 1.19. What is the ratio of the Balance of Payment (as % of service exports) in Djibouti in 2010 to that in 2012?
Your answer should be very brief. 0.89. What is the ratio of the Balance of Payment (as % of service exports) in Guinea in 2010 to that in 2012?
Make the answer very short. 3.69. What is the ratio of the Balance of Payment (as % of service exports) of Marshall Islands in 2010 to that in 2012?
Your answer should be compact. 0.98. What is the ratio of the Balance of Payment (as % of service exports) in Tonga in 2010 to that in 2012?
Offer a very short reply. 1.03. What is the ratio of the Balance of Payment (as % of service exports) in Djibouti in 2011 to that in 2012?
Ensure brevity in your answer.  0.97. What is the ratio of the Balance of Payment (as % of service exports) in Guinea in 2011 to that in 2012?
Your answer should be very brief. 3.06. What is the ratio of the Balance of Payment (as % of service exports) of Marshall Islands in 2011 to that in 2012?
Provide a short and direct response. 1.02. What is the ratio of the Balance of Payment (as % of service exports) of Tonga in 2011 to that in 2012?
Your answer should be very brief. 0.86. What is the difference between the highest and the second highest Balance of Payment (as % of service exports) in Djibouti?
Your response must be concise. 0.17. What is the difference between the highest and the second highest Balance of Payment (as % of service exports) of Guinea?
Provide a succinct answer. 0.59. What is the difference between the highest and the second highest Balance of Payment (as % of service exports) of Marshall Islands?
Give a very brief answer. 0.69. What is the difference between the highest and the second highest Balance of Payment (as % of service exports) in Tonga?
Provide a succinct answer. 1.62. What is the difference between the highest and the lowest Balance of Payment (as % of service exports) in Djibouti?
Keep it short and to the point. 3.5. What is the difference between the highest and the lowest Balance of Payment (as % of service exports) of Guinea?
Provide a short and direct response. 3.47. What is the difference between the highest and the lowest Balance of Payment (as % of service exports) in Marshall Islands?
Keep it short and to the point. 8.47. What is the difference between the highest and the lowest Balance of Payment (as % of service exports) of Tonga?
Make the answer very short. 9.04. 